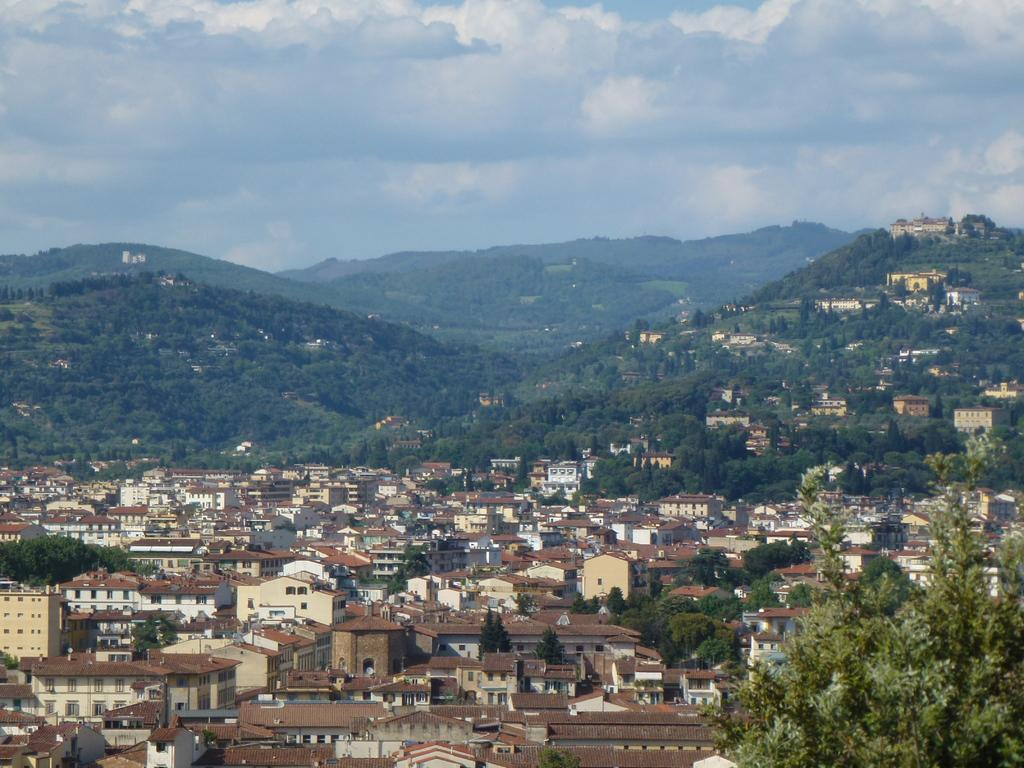What type of structures can be seen in the image? There are buildings in the image. What other natural elements are present in the image? There are trees and hills in the image. What part of the natural environment is visible in the image? The sky is visible in the image. What type of soap is being used to clean the buildings in the image? There is no soap or cleaning activity depicted in the image; it simply shows buildings, trees, hills, and the sky. 